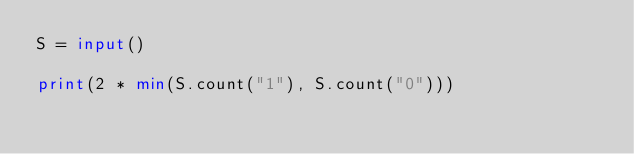<code> <loc_0><loc_0><loc_500><loc_500><_Python_>S = input()

print(2 * min(S.count("1"), S.count("0")))</code> 